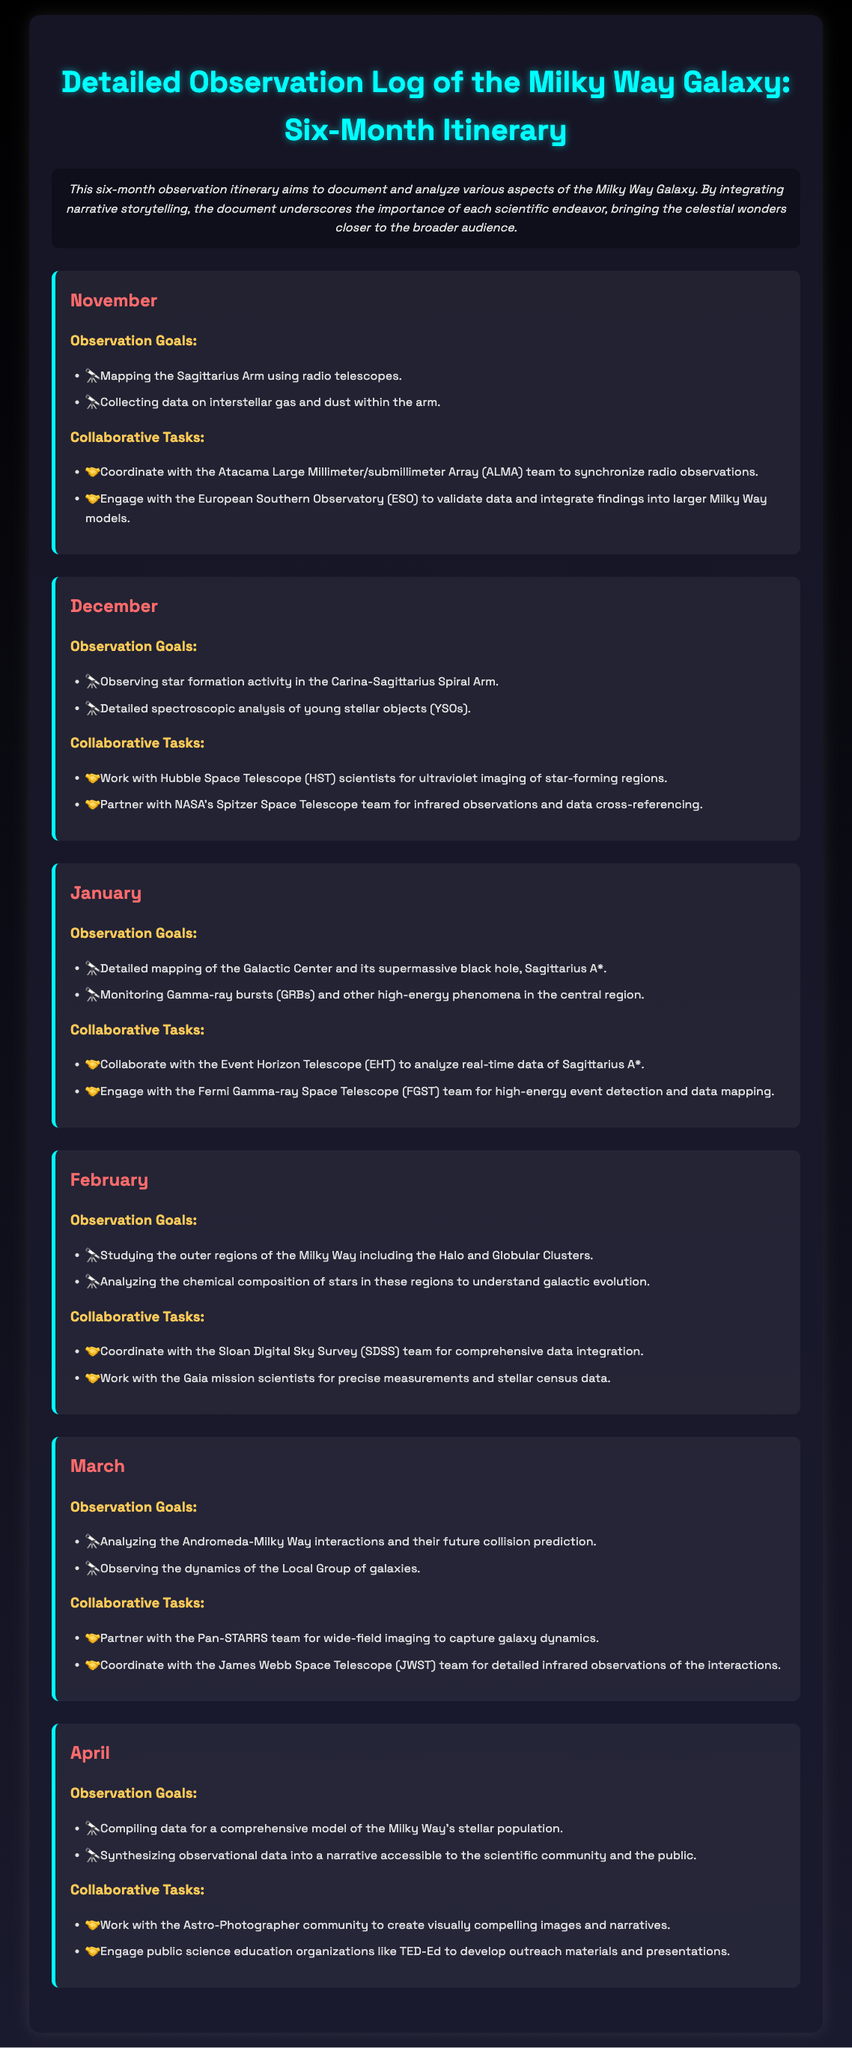What are the observation goals for November? The observation goals for November are mapping the Sagittarius Arm and collecting data on interstellar gas and dust.
Answer: Mapping the Sagittarius Arm, collecting data on interstellar gas and dust How many months does the observation itinerary cover? The itinerary spans a period of six months, from November to April.
Answer: Six months Which telescope team is collaborating in January? The Event Horizon Telescope team is collaborating in January to analyze real-time data of Sagittarius A*.
Answer: Event Horizon Telescope What is the main focus of February's observation goals? February's observation goals focus on studying the outer regions of the Milky Way, including the Halo and Globular Clusters.
Answer: Studying the outer regions, Halo, and Globular Clusters What type of data integration is planned for April? In April, comprehensive model data of the Milky Way's stellar population will be compiled.
Answer: Comprehensive model of the Milky Way's stellar population How will the findings be presented in April? In April, observational data will be synthesized into a narrative accessible to the scientific community and the public.
Answer: Narrative accessible to the scientific community and public 